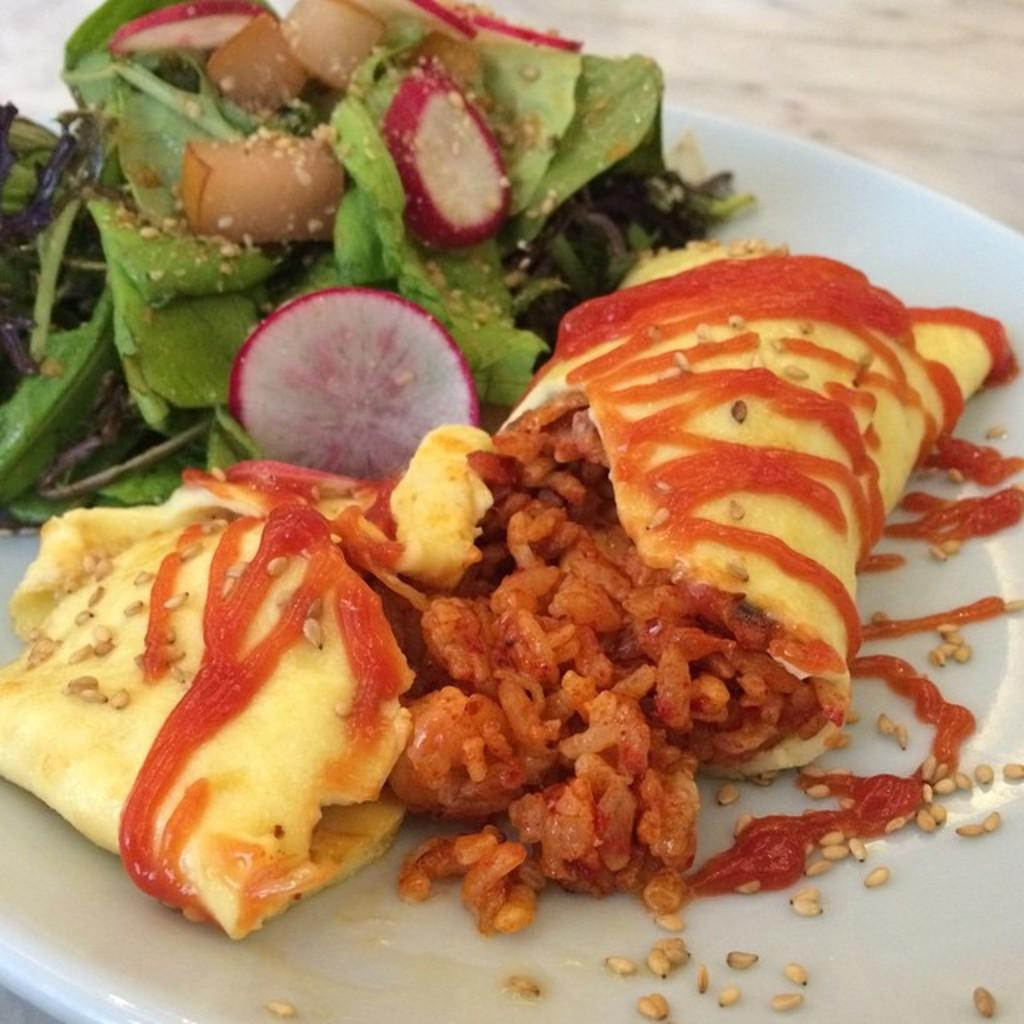What is present in the image that is being served? There is a dish in the image that is being served. How is the dish being served? The dish is served in a plate. What color is visible at the top of the image? There is blue visible at the top of the image. What type of doctor is present in the image? There is no doctor present in the image. What religious symbol can be seen in the image? There is no religious symbol present in the image. What type of prison is depicted in the image? There is no prison depicted in the image. 